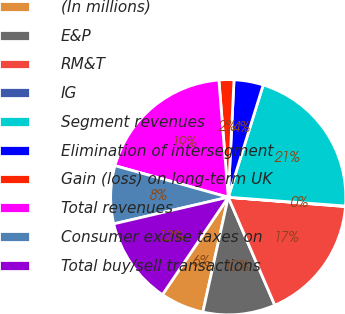Convert chart. <chart><loc_0><loc_0><loc_500><loc_500><pie_chart><fcel>(In millions)<fcel>E&P<fcel>RM&T<fcel>IG<fcel>Segment revenues<fcel>Elimination of intersegment<fcel>Gain (loss) on long-term UK<fcel>Total revenues<fcel>Consumer excise taxes on<fcel>Total buy/sell transactions<nl><fcel>5.99%<fcel>9.94%<fcel>17.26%<fcel>0.07%<fcel>21.39%<fcel>4.02%<fcel>2.05%<fcel>19.41%<fcel>7.96%<fcel>11.91%<nl></chart> 